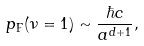<formula> <loc_0><loc_0><loc_500><loc_500>p _ { \text {F} } ( \nu = 1 ) \sim \frac { \hbar { c } } { a ^ { d + 1 } } ,</formula> 